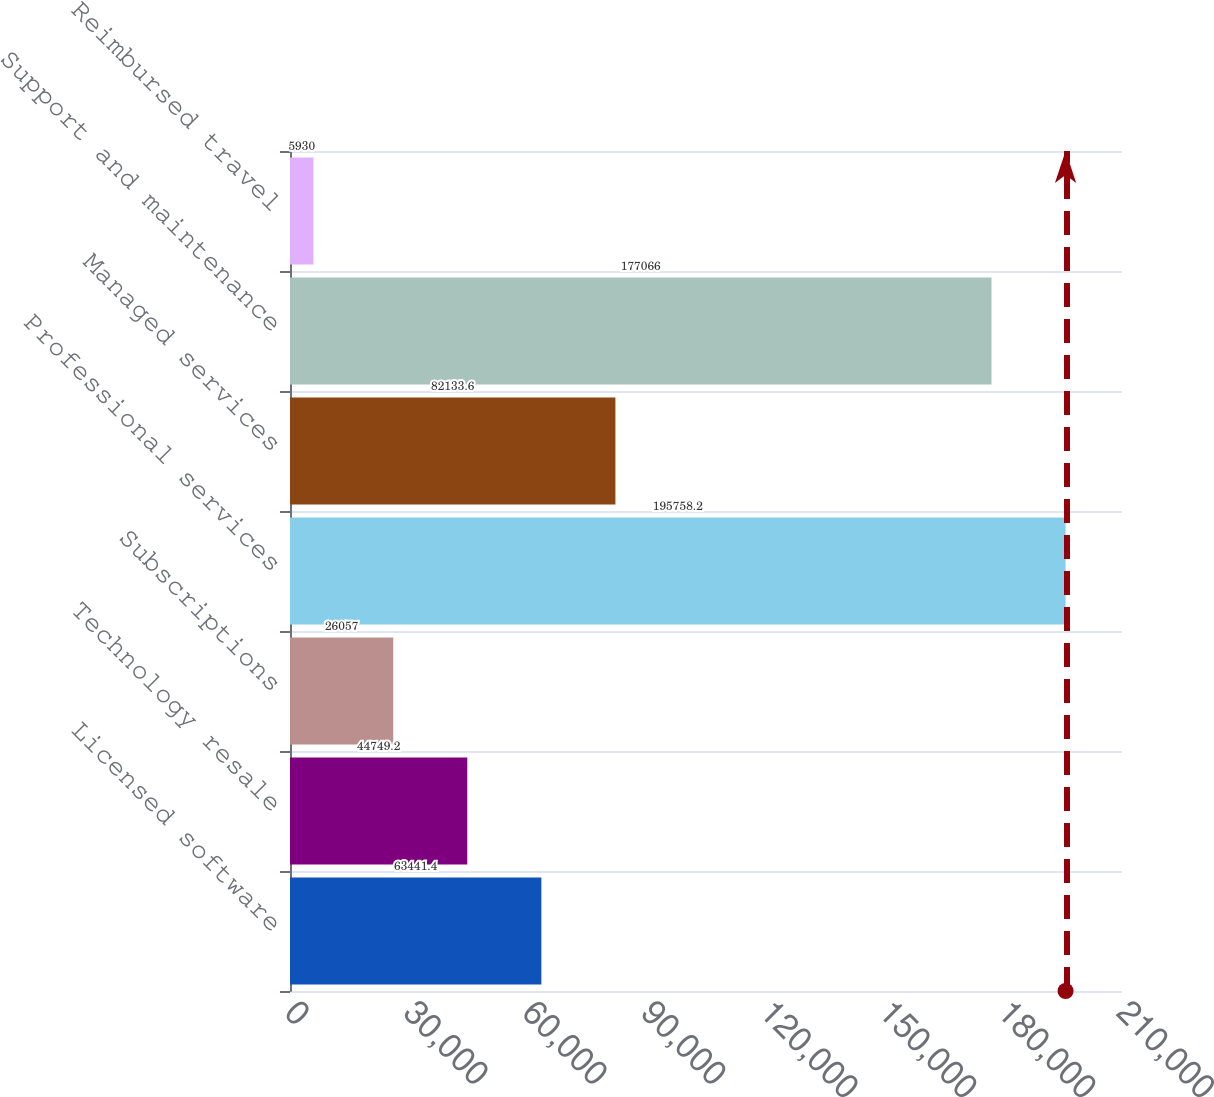Convert chart to OTSL. <chart><loc_0><loc_0><loc_500><loc_500><bar_chart><fcel>Licensed software<fcel>Technology resale<fcel>Subscriptions<fcel>Professional services<fcel>Managed services<fcel>Support and maintenance<fcel>Reimbursed travel<nl><fcel>63441.4<fcel>44749.2<fcel>26057<fcel>195758<fcel>82133.6<fcel>177066<fcel>5930<nl></chart> 